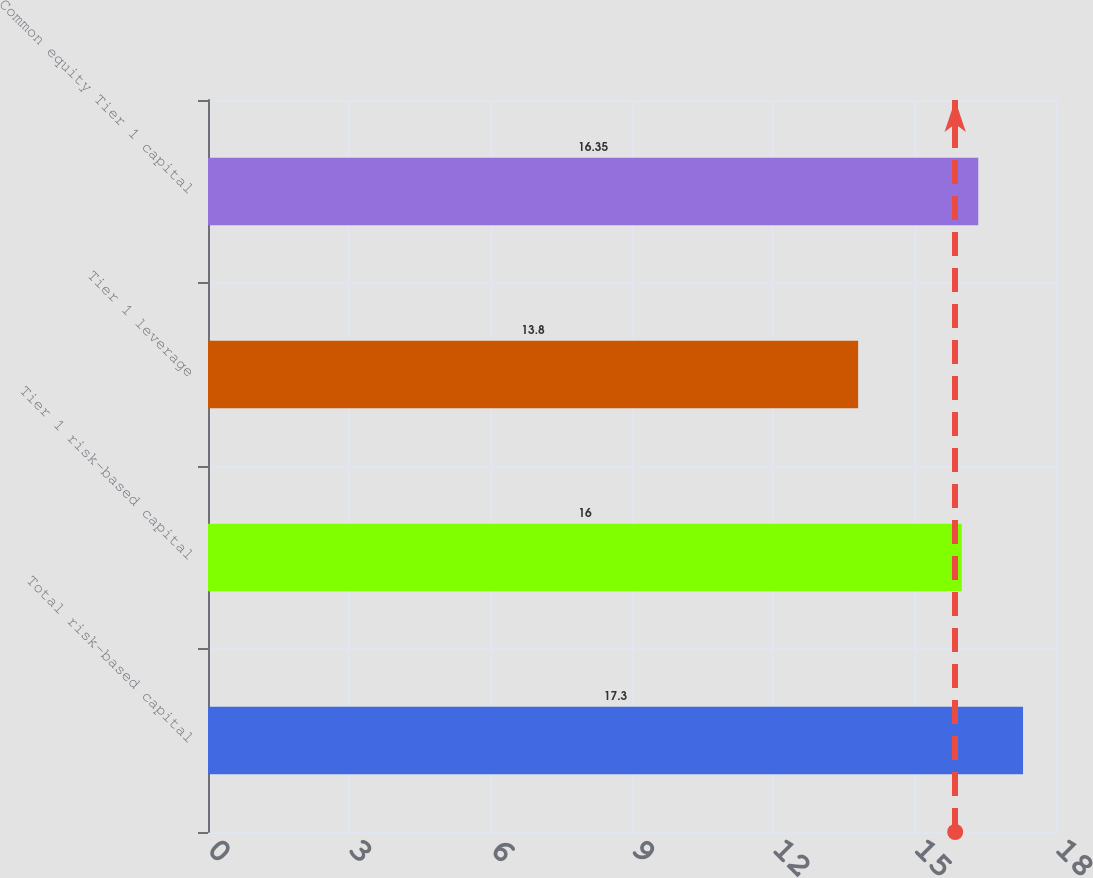Convert chart to OTSL. <chart><loc_0><loc_0><loc_500><loc_500><bar_chart><fcel>Total risk-based capital<fcel>Tier 1 risk-based capital<fcel>Tier 1 leverage<fcel>Common equity Tier 1 capital<nl><fcel>17.3<fcel>16<fcel>13.8<fcel>16.35<nl></chart> 